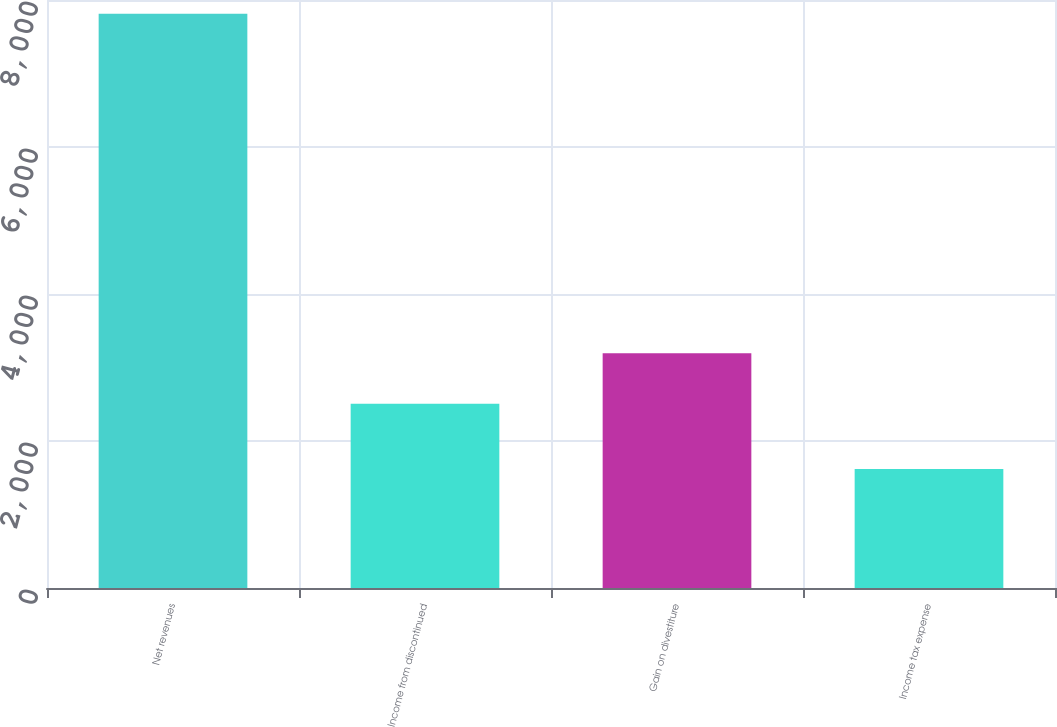Convert chart. <chart><loc_0><loc_0><loc_500><loc_500><bar_chart><fcel>Net revenues<fcel>Income from discontinued<fcel>Gain on divestiture<fcel>Income tax expense<nl><fcel>7813<fcel>2506<fcel>3194.1<fcel>1620.1<nl></chart> 